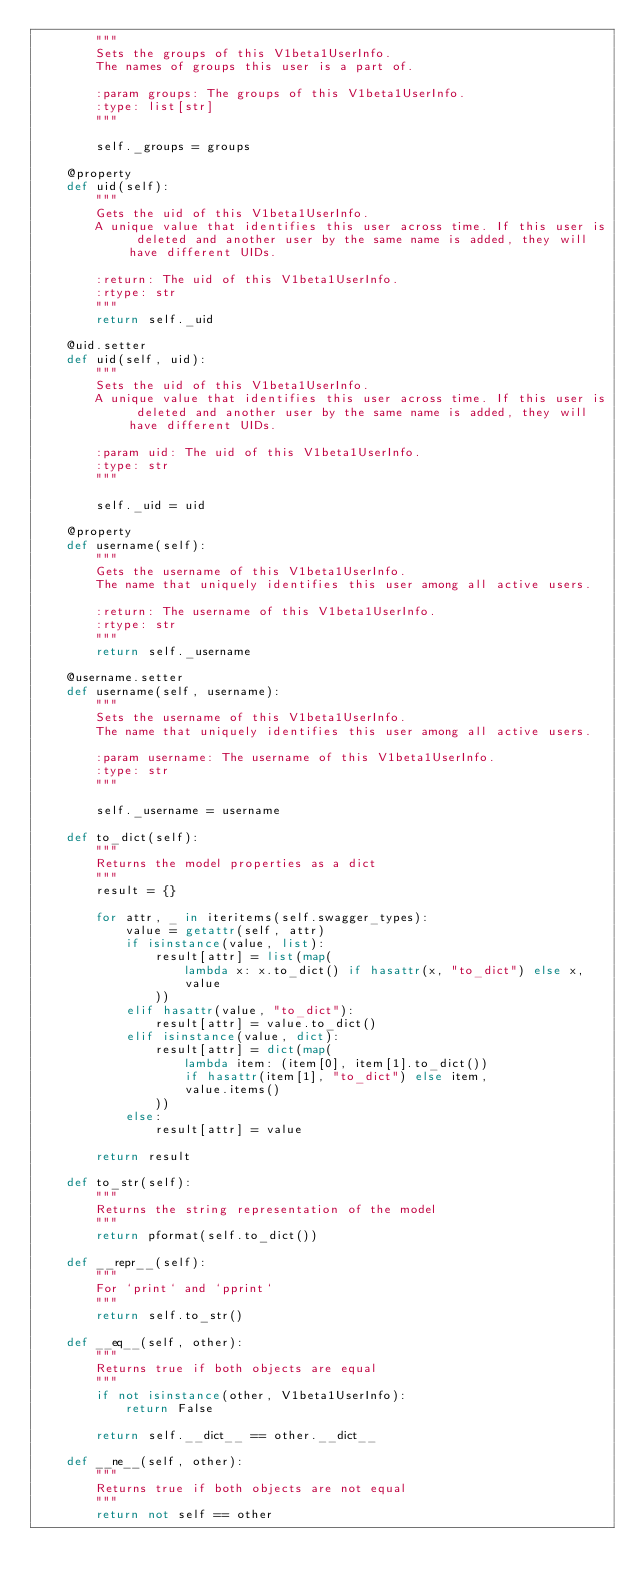<code> <loc_0><loc_0><loc_500><loc_500><_Python_>        """
        Sets the groups of this V1beta1UserInfo.
        The names of groups this user is a part of.

        :param groups: The groups of this V1beta1UserInfo.
        :type: list[str]
        """

        self._groups = groups

    @property
    def uid(self):
        """
        Gets the uid of this V1beta1UserInfo.
        A unique value that identifies this user across time. If this user is deleted and another user by the same name is added, they will have different UIDs.

        :return: The uid of this V1beta1UserInfo.
        :rtype: str
        """
        return self._uid

    @uid.setter
    def uid(self, uid):
        """
        Sets the uid of this V1beta1UserInfo.
        A unique value that identifies this user across time. If this user is deleted and another user by the same name is added, they will have different UIDs.

        :param uid: The uid of this V1beta1UserInfo.
        :type: str
        """

        self._uid = uid

    @property
    def username(self):
        """
        Gets the username of this V1beta1UserInfo.
        The name that uniquely identifies this user among all active users.

        :return: The username of this V1beta1UserInfo.
        :rtype: str
        """
        return self._username

    @username.setter
    def username(self, username):
        """
        Sets the username of this V1beta1UserInfo.
        The name that uniquely identifies this user among all active users.

        :param username: The username of this V1beta1UserInfo.
        :type: str
        """

        self._username = username

    def to_dict(self):
        """
        Returns the model properties as a dict
        """
        result = {}

        for attr, _ in iteritems(self.swagger_types):
            value = getattr(self, attr)
            if isinstance(value, list):
                result[attr] = list(map(
                    lambda x: x.to_dict() if hasattr(x, "to_dict") else x,
                    value
                ))
            elif hasattr(value, "to_dict"):
                result[attr] = value.to_dict()
            elif isinstance(value, dict):
                result[attr] = dict(map(
                    lambda item: (item[0], item[1].to_dict())
                    if hasattr(item[1], "to_dict") else item,
                    value.items()
                ))
            else:
                result[attr] = value

        return result

    def to_str(self):
        """
        Returns the string representation of the model
        """
        return pformat(self.to_dict())

    def __repr__(self):
        """
        For `print` and `pprint`
        """
        return self.to_str()

    def __eq__(self, other):
        """
        Returns true if both objects are equal
        """
        if not isinstance(other, V1beta1UserInfo):
            return False

        return self.__dict__ == other.__dict__

    def __ne__(self, other):
        """
        Returns true if both objects are not equal
        """
        return not self == other
</code> 